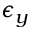<formula> <loc_0><loc_0><loc_500><loc_500>\epsilon _ { y }</formula> 